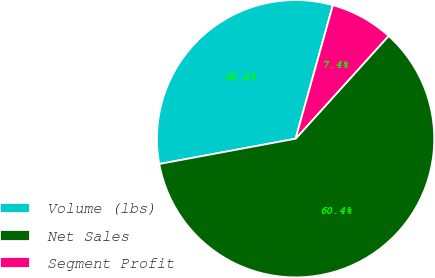<chart> <loc_0><loc_0><loc_500><loc_500><pie_chart><fcel>Volume (lbs)<fcel>Net Sales<fcel>Segment Profit<nl><fcel>32.25%<fcel>60.38%<fcel>7.37%<nl></chart> 